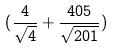<formula> <loc_0><loc_0><loc_500><loc_500>( \frac { 4 } { \sqrt { 4 } } + \frac { 4 0 5 } { \sqrt { 2 0 1 } } )</formula> 